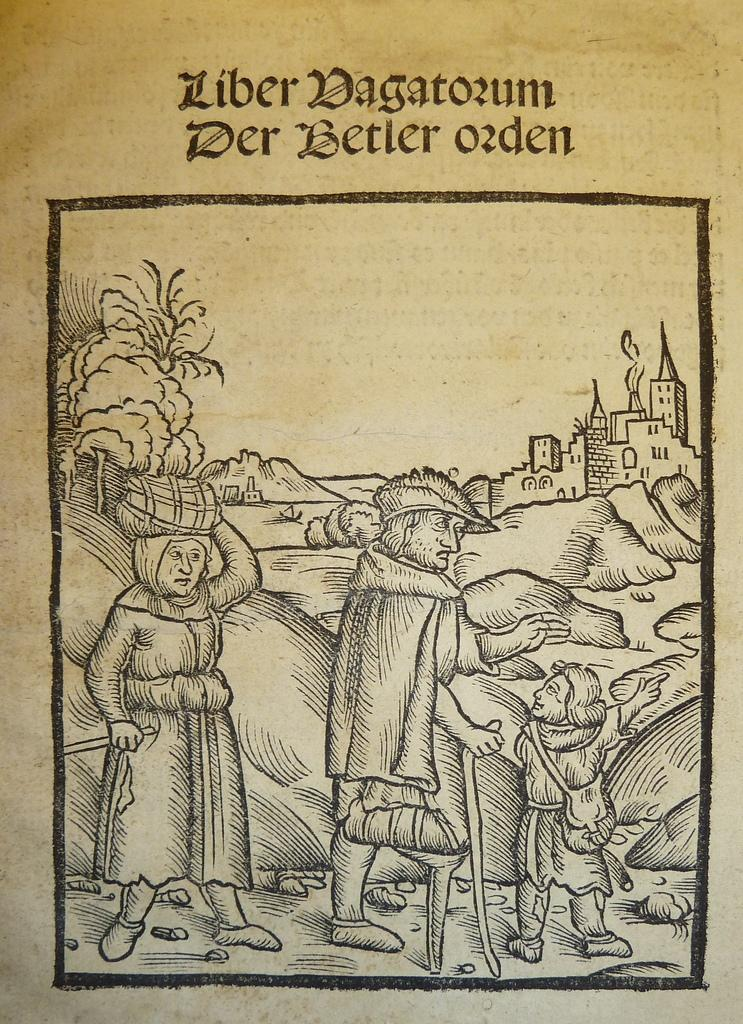What type of artwork is featured in the image? The image contains a sketch painting. Can you describe the style or subject of the sketch painting? The sketch painting appears to be an illustration. How many hills can be seen in the glove depicted in the image? There is no glove or hill present in the image; it features a sketch painting that appears to be an illustration. 